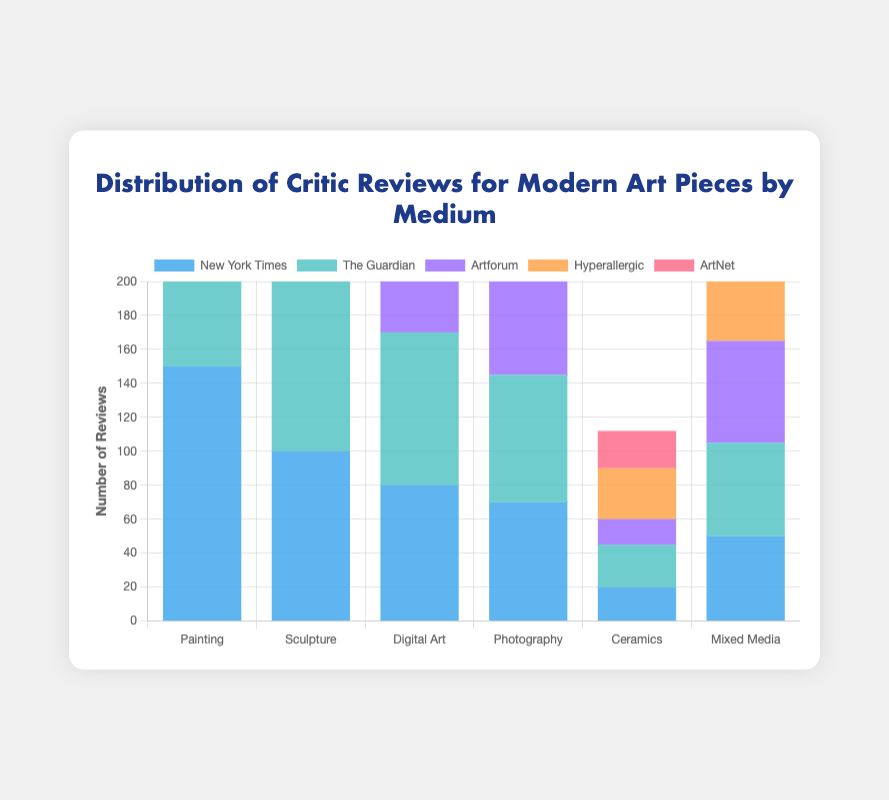Which medium received the highest number of reviews from the New York Times? In the New York Times dataset, Painting has the highest number of reviews at 150.
Answer: Painting How many reviews did Hyperallergic give to Ceramics? Hyperallergic gave 30 reviews to Ceramics as shown by the height of the corresponding bar.
Answer: 30 Which medium obtained more reviews from Artforum, Digital Art or Photography? Comparing the two bars for Artforum, Digital Art received 85 reviews, and Photography received 65 reviews, making Digital Art the one with more reviews.
Answer: Digital Art What is the total number of reviews received by Sculpture across all sources? Sum the number of reviews for Sculpture from each of the five sources (100+110+115+120+105).
Answer: 550 Which medium has the least number of reviews from The Guardian? By observing the height of the bars under The Guardian, Ceramics received the least number of reviews at 25.
Answer: Ceramics Does Mixed Media have more reviews from Hyperallergic or ArtNet? Mixed Media received 65 reviews from Hyperallergic and 52 from ArtNet. Therefore, Hyperallergic reviewed more.
Answer: Hyperallergic What is the average number of reviews received by Painting across all critics? Add the reviews for Painting from all sources and divide by the number of sources (150+140+130+160+145)/5 = 725/5.
Answer: 145 Which critic gave the highest total number of reviews for all mediums? Summing the reviews for all mediums from each critic, Hyperallergic provided the highest: Painting (160) + Sculpture (120) + Digital Art (95) + Photography (80) + Ceramics (30) + Mixed Media (65) = 550.
Answer: Hyperallergic Is the number of reviews for Photography from ArtNet greater than the number from New York Times? ArtNet reviewed Photography 78 times and New York Times reviewed it 70 times. Therefore, ArtNet's reviews are greater.
Answer: Yes 